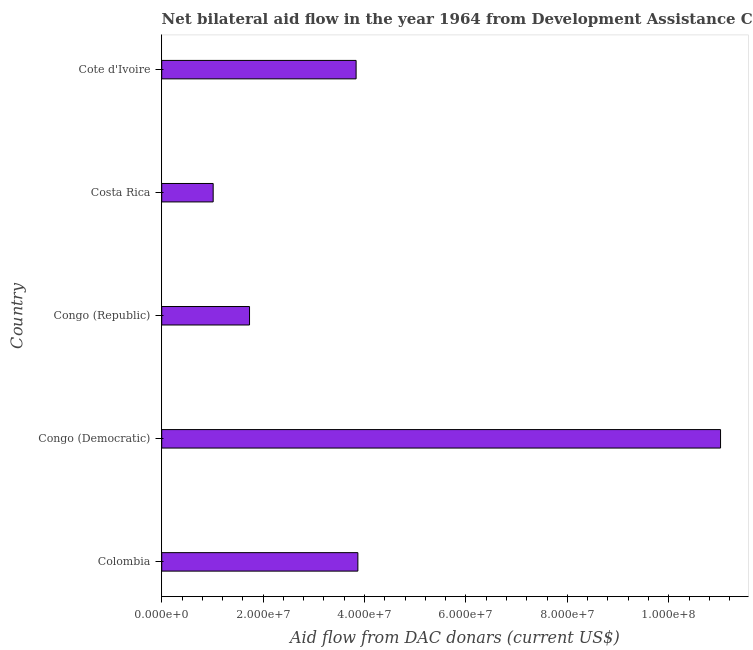Does the graph contain grids?
Provide a short and direct response. No. What is the title of the graph?
Your response must be concise. Net bilateral aid flow in the year 1964 from Development Assistance Committee. What is the label or title of the X-axis?
Ensure brevity in your answer.  Aid flow from DAC donars (current US$). What is the label or title of the Y-axis?
Offer a terse response. Country. What is the net bilateral aid flows from dac donors in Costa Rica?
Give a very brief answer. 1.02e+07. Across all countries, what is the maximum net bilateral aid flows from dac donors?
Give a very brief answer. 1.10e+08. Across all countries, what is the minimum net bilateral aid flows from dac donors?
Provide a succinct answer. 1.02e+07. In which country was the net bilateral aid flows from dac donors maximum?
Keep it short and to the point. Congo (Democratic). What is the sum of the net bilateral aid flows from dac donors?
Keep it short and to the point. 2.15e+08. What is the difference between the net bilateral aid flows from dac donors in Congo (Democratic) and Costa Rica?
Make the answer very short. 1.00e+08. What is the average net bilateral aid flows from dac donors per country?
Provide a short and direct response. 4.29e+07. What is the median net bilateral aid flows from dac donors?
Provide a succinct answer. 3.83e+07. In how many countries, is the net bilateral aid flows from dac donors greater than 64000000 US$?
Provide a succinct answer. 1. What is the ratio of the net bilateral aid flows from dac donors in Costa Rica to that in Cote d'Ivoire?
Give a very brief answer. 0.27. What is the difference between the highest and the second highest net bilateral aid flows from dac donors?
Keep it short and to the point. 7.15e+07. Is the sum of the net bilateral aid flows from dac donors in Congo (Republic) and Costa Rica greater than the maximum net bilateral aid flows from dac donors across all countries?
Your response must be concise. No. What is the difference between the highest and the lowest net bilateral aid flows from dac donors?
Your answer should be compact. 1.00e+08. In how many countries, is the net bilateral aid flows from dac donors greater than the average net bilateral aid flows from dac donors taken over all countries?
Offer a terse response. 1. How many bars are there?
Your answer should be compact. 5. What is the Aid flow from DAC donars (current US$) of Colombia?
Your response must be concise. 3.87e+07. What is the Aid flow from DAC donars (current US$) in Congo (Democratic)?
Ensure brevity in your answer.  1.10e+08. What is the Aid flow from DAC donars (current US$) of Congo (Republic)?
Ensure brevity in your answer.  1.73e+07. What is the Aid flow from DAC donars (current US$) in Costa Rica?
Your answer should be compact. 1.02e+07. What is the Aid flow from DAC donars (current US$) in Cote d'Ivoire?
Give a very brief answer. 3.83e+07. What is the difference between the Aid flow from DAC donars (current US$) in Colombia and Congo (Democratic)?
Give a very brief answer. -7.15e+07. What is the difference between the Aid flow from DAC donars (current US$) in Colombia and Congo (Republic)?
Make the answer very short. 2.14e+07. What is the difference between the Aid flow from DAC donars (current US$) in Colombia and Costa Rica?
Keep it short and to the point. 2.85e+07. What is the difference between the Aid flow from DAC donars (current US$) in Congo (Democratic) and Congo (Republic)?
Make the answer very short. 9.29e+07. What is the difference between the Aid flow from DAC donars (current US$) in Congo (Democratic) and Costa Rica?
Provide a short and direct response. 1.00e+08. What is the difference between the Aid flow from DAC donars (current US$) in Congo (Democratic) and Cote d'Ivoire?
Your response must be concise. 7.19e+07. What is the difference between the Aid flow from DAC donars (current US$) in Congo (Republic) and Costa Rica?
Ensure brevity in your answer.  7.17e+06. What is the difference between the Aid flow from DAC donars (current US$) in Congo (Republic) and Cote d'Ivoire?
Your answer should be very brief. -2.10e+07. What is the difference between the Aid flow from DAC donars (current US$) in Costa Rica and Cote d'Ivoire?
Your response must be concise. -2.82e+07. What is the ratio of the Aid flow from DAC donars (current US$) in Colombia to that in Congo (Democratic)?
Offer a terse response. 0.35. What is the ratio of the Aid flow from DAC donars (current US$) in Colombia to that in Congo (Republic)?
Give a very brief answer. 2.23. What is the ratio of the Aid flow from DAC donars (current US$) in Colombia to that in Costa Rica?
Ensure brevity in your answer.  3.81. What is the ratio of the Aid flow from DAC donars (current US$) in Congo (Democratic) to that in Congo (Republic)?
Offer a terse response. 6.36. What is the ratio of the Aid flow from DAC donars (current US$) in Congo (Democratic) to that in Costa Rica?
Make the answer very short. 10.86. What is the ratio of the Aid flow from DAC donars (current US$) in Congo (Democratic) to that in Cote d'Ivoire?
Give a very brief answer. 2.88. What is the ratio of the Aid flow from DAC donars (current US$) in Congo (Republic) to that in Costa Rica?
Keep it short and to the point. 1.71. What is the ratio of the Aid flow from DAC donars (current US$) in Congo (Republic) to that in Cote d'Ivoire?
Your answer should be compact. 0.45. What is the ratio of the Aid flow from DAC donars (current US$) in Costa Rica to that in Cote d'Ivoire?
Offer a terse response. 0.27. 